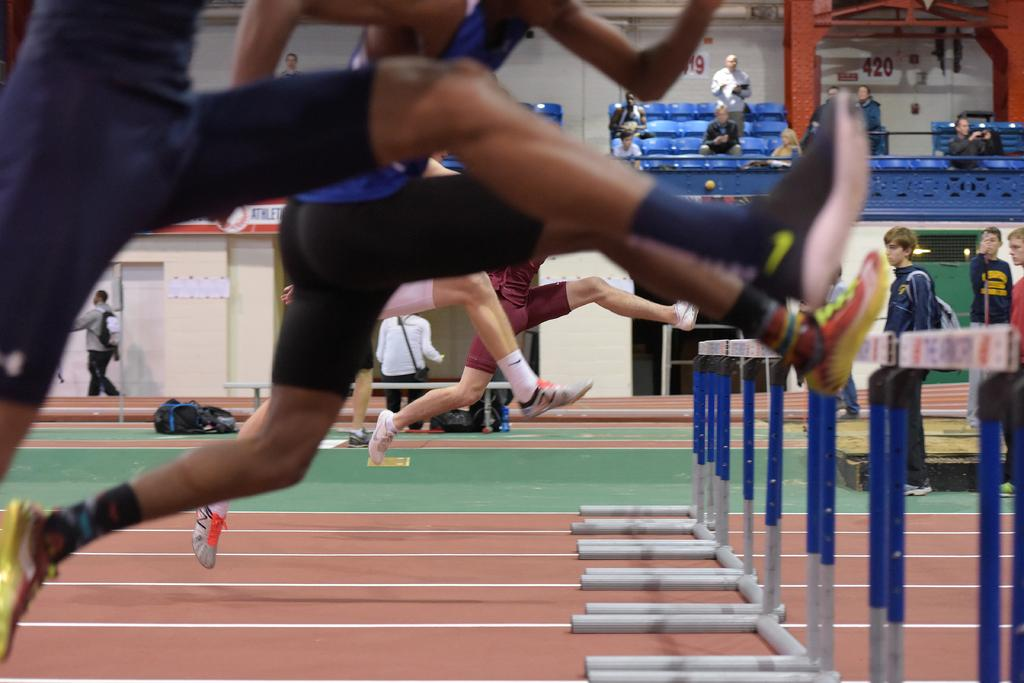What are the people in the image doing? The people in the image are jumping. Where are the people standing in the image? There are people standing on the floor on the right side of the image. What can be seen in the background of the image? There is a wall in the background of the image. What type of cap is the person wearing in the image? There is no person wearing a cap in the image; the people are jumping and standing without any visible headwear. 